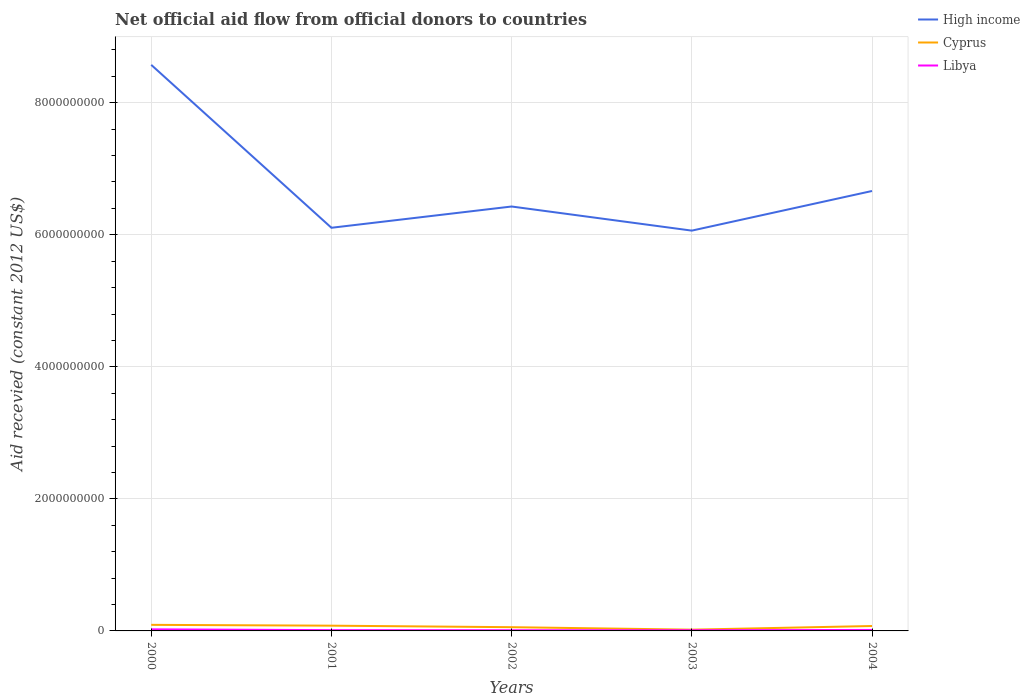Does the line corresponding to Cyprus intersect with the line corresponding to High income?
Ensure brevity in your answer.  No. Across all years, what is the maximum total aid received in Cyprus?
Keep it short and to the point. 1.92e+07. What is the total total aid received in Cyprus in the graph?
Your response must be concise. -1.78e+07. What is the difference between the highest and the second highest total aid received in High income?
Provide a succinct answer. 2.51e+09. How many lines are there?
Keep it short and to the point. 3. What is the difference between two consecutive major ticks on the Y-axis?
Give a very brief answer. 2.00e+09. Does the graph contain any zero values?
Ensure brevity in your answer.  No. Does the graph contain grids?
Ensure brevity in your answer.  Yes. Where does the legend appear in the graph?
Keep it short and to the point. Top right. How many legend labels are there?
Provide a succinct answer. 3. How are the legend labels stacked?
Offer a terse response. Vertical. What is the title of the graph?
Keep it short and to the point. Net official aid flow from official donors to countries. What is the label or title of the X-axis?
Make the answer very short. Years. What is the label or title of the Y-axis?
Ensure brevity in your answer.  Aid recevied (constant 2012 US$). What is the Aid recevied (constant 2012 US$) of High income in 2000?
Provide a short and direct response. 8.57e+09. What is the Aid recevied (constant 2012 US$) in Cyprus in 2000?
Ensure brevity in your answer.  9.20e+07. What is the Aid recevied (constant 2012 US$) of Libya in 2000?
Give a very brief answer. 2.38e+07. What is the Aid recevied (constant 2012 US$) of High income in 2001?
Provide a short and direct response. 6.11e+09. What is the Aid recevied (constant 2012 US$) in Cyprus in 2001?
Keep it short and to the point. 7.95e+07. What is the Aid recevied (constant 2012 US$) of Libya in 2001?
Provide a short and direct response. 1.17e+07. What is the Aid recevied (constant 2012 US$) of High income in 2002?
Your answer should be compact. 6.43e+09. What is the Aid recevied (constant 2012 US$) of Cyprus in 2002?
Your answer should be very brief. 5.66e+07. What is the Aid recevied (constant 2012 US$) in Libya in 2002?
Offer a terse response. 1.05e+07. What is the Aid recevied (constant 2012 US$) of High income in 2003?
Your answer should be compact. 6.06e+09. What is the Aid recevied (constant 2012 US$) in Cyprus in 2003?
Provide a short and direct response. 1.92e+07. What is the Aid recevied (constant 2012 US$) in Libya in 2003?
Give a very brief answer. 1.03e+07. What is the Aid recevied (constant 2012 US$) of High income in 2004?
Provide a short and direct response. 6.66e+09. What is the Aid recevied (constant 2012 US$) in Cyprus in 2004?
Offer a terse response. 7.44e+07. What is the Aid recevied (constant 2012 US$) in Libya in 2004?
Offer a very short reply. 1.50e+07. Across all years, what is the maximum Aid recevied (constant 2012 US$) in High income?
Ensure brevity in your answer.  8.57e+09. Across all years, what is the maximum Aid recevied (constant 2012 US$) of Cyprus?
Give a very brief answer. 9.20e+07. Across all years, what is the maximum Aid recevied (constant 2012 US$) in Libya?
Provide a succinct answer. 2.38e+07. Across all years, what is the minimum Aid recevied (constant 2012 US$) of High income?
Your response must be concise. 6.06e+09. Across all years, what is the minimum Aid recevied (constant 2012 US$) in Cyprus?
Ensure brevity in your answer.  1.92e+07. Across all years, what is the minimum Aid recevied (constant 2012 US$) in Libya?
Provide a succinct answer. 1.03e+07. What is the total Aid recevied (constant 2012 US$) of High income in the graph?
Provide a short and direct response. 3.38e+1. What is the total Aid recevied (constant 2012 US$) of Cyprus in the graph?
Your response must be concise. 3.22e+08. What is the total Aid recevied (constant 2012 US$) in Libya in the graph?
Provide a short and direct response. 7.14e+07. What is the difference between the Aid recevied (constant 2012 US$) of High income in 2000 and that in 2001?
Offer a very short reply. 2.47e+09. What is the difference between the Aid recevied (constant 2012 US$) of Cyprus in 2000 and that in 2001?
Keep it short and to the point. 1.25e+07. What is the difference between the Aid recevied (constant 2012 US$) of Libya in 2000 and that in 2001?
Provide a short and direct response. 1.21e+07. What is the difference between the Aid recevied (constant 2012 US$) in High income in 2000 and that in 2002?
Your answer should be very brief. 2.15e+09. What is the difference between the Aid recevied (constant 2012 US$) of Cyprus in 2000 and that in 2002?
Ensure brevity in your answer.  3.53e+07. What is the difference between the Aid recevied (constant 2012 US$) in Libya in 2000 and that in 2002?
Offer a terse response. 1.33e+07. What is the difference between the Aid recevied (constant 2012 US$) of High income in 2000 and that in 2003?
Keep it short and to the point. 2.51e+09. What is the difference between the Aid recevied (constant 2012 US$) of Cyprus in 2000 and that in 2003?
Your answer should be very brief. 7.27e+07. What is the difference between the Aid recevied (constant 2012 US$) of Libya in 2000 and that in 2003?
Offer a terse response. 1.34e+07. What is the difference between the Aid recevied (constant 2012 US$) of High income in 2000 and that in 2004?
Offer a very short reply. 1.91e+09. What is the difference between the Aid recevied (constant 2012 US$) in Cyprus in 2000 and that in 2004?
Provide a succinct answer. 1.76e+07. What is the difference between the Aid recevied (constant 2012 US$) in Libya in 2000 and that in 2004?
Ensure brevity in your answer.  8.78e+06. What is the difference between the Aid recevied (constant 2012 US$) of High income in 2001 and that in 2002?
Offer a very short reply. -3.22e+08. What is the difference between the Aid recevied (constant 2012 US$) of Cyprus in 2001 and that in 2002?
Make the answer very short. 2.28e+07. What is the difference between the Aid recevied (constant 2012 US$) in Libya in 2001 and that in 2002?
Your answer should be very brief. 1.22e+06. What is the difference between the Aid recevied (constant 2012 US$) in High income in 2001 and that in 2003?
Provide a succinct answer. 4.32e+07. What is the difference between the Aid recevied (constant 2012 US$) of Cyprus in 2001 and that in 2003?
Your answer should be very brief. 6.02e+07. What is the difference between the Aid recevied (constant 2012 US$) of Libya in 2001 and that in 2003?
Offer a terse response. 1.39e+06. What is the difference between the Aid recevied (constant 2012 US$) of High income in 2001 and that in 2004?
Your response must be concise. -5.57e+08. What is the difference between the Aid recevied (constant 2012 US$) of Cyprus in 2001 and that in 2004?
Offer a terse response. 5.07e+06. What is the difference between the Aid recevied (constant 2012 US$) in Libya in 2001 and that in 2004?
Make the answer very short. -3.28e+06. What is the difference between the Aid recevied (constant 2012 US$) of High income in 2002 and that in 2003?
Keep it short and to the point. 3.65e+08. What is the difference between the Aid recevied (constant 2012 US$) in Cyprus in 2002 and that in 2003?
Offer a very short reply. 3.74e+07. What is the difference between the Aid recevied (constant 2012 US$) of High income in 2002 and that in 2004?
Your answer should be compact. -2.35e+08. What is the difference between the Aid recevied (constant 2012 US$) of Cyprus in 2002 and that in 2004?
Offer a terse response. -1.78e+07. What is the difference between the Aid recevied (constant 2012 US$) of Libya in 2002 and that in 2004?
Your answer should be compact. -4.50e+06. What is the difference between the Aid recevied (constant 2012 US$) in High income in 2003 and that in 2004?
Your answer should be compact. -6.00e+08. What is the difference between the Aid recevied (constant 2012 US$) of Cyprus in 2003 and that in 2004?
Keep it short and to the point. -5.52e+07. What is the difference between the Aid recevied (constant 2012 US$) in Libya in 2003 and that in 2004?
Keep it short and to the point. -4.67e+06. What is the difference between the Aid recevied (constant 2012 US$) of High income in 2000 and the Aid recevied (constant 2012 US$) of Cyprus in 2001?
Give a very brief answer. 8.49e+09. What is the difference between the Aid recevied (constant 2012 US$) in High income in 2000 and the Aid recevied (constant 2012 US$) in Libya in 2001?
Your answer should be compact. 8.56e+09. What is the difference between the Aid recevied (constant 2012 US$) in Cyprus in 2000 and the Aid recevied (constant 2012 US$) in Libya in 2001?
Give a very brief answer. 8.02e+07. What is the difference between the Aid recevied (constant 2012 US$) of High income in 2000 and the Aid recevied (constant 2012 US$) of Cyprus in 2002?
Offer a terse response. 8.52e+09. What is the difference between the Aid recevied (constant 2012 US$) of High income in 2000 and the Aid recevied (constant 2012 US$) of Libya in 2002?
Offer a very short reply. 8.56e+09. What is the difference between the Aid recevied (constant 2012 US$) in Cyprus in 2000 and the Aid recevied (constant 2012 US$) in Libya in 2002?
Offer a terse response. 8.15e+07. What is the difference between the Aid recevied (constant 2012 US$) in High income in 2000 and the Aid recevied (constant 2012 US$) in Cyprus in 2003?
Offer a terse response. 8.55e+09. What is the difference between the Aid recevied (constant 2012 US$) in High income in 2000 and the Aid recevied (constant 2012 US$) in Libya in 2003?
Provide a short and direct response. 8.56e+09. What is the difference between the Aid recevied (constant 2012 US$) of Cyprus in 2000 and the Aid recevied (constant 2012 US$) of Libya in 2003?
Offer a terse response. 8.16e+07. What is the difference between the Aid recevied (constant 2012 US$) of High income in 2000 and the Aid recevied (constant 2012 US$) of Cyprus in 2004?
Your response must be concise. 8.50e+09. What is the difference between the Aid recevied (constant 2012 US$) of High income in 2000 and the Aid recevied (constant 2012 US$) of Libya in 2004?
Provide a short and direct response. 8.56e+09. What is the difference between the Aid recevied (constant 2012 US$) in Cyprus in 2000 and the Aid recevied (constant 2012 US$) in Libya in 2004?
Provide a short and direct response. 7.70e+07. What is the difference between the Aid recevied (constant 2012 US$) in High income in 2001 and the Aid recevied (constant 2012 US$) in Cyprus in 2002?
Give a very brief answer. 6.05e+09. What is the difference between the Aid recevied (constant 2012 US$) in High income in 2001 and the Aid recevied (constant 2012 US$) in Libya in 2002?
Make the answer very short. 6.10e+09. What is the difference between the Aid recevied (constant 2012 US$) in Cyprus in 2001 and the Aid recevied (constant 2012 US$) in Libya in 2002?
Your answer should be very brief. 6.90e+07. What is the difference between the Aid recevied (constant 2012 US$) in High income in 2001 and the Aid recevied (constant 2012 US$) in Cyprus in 2003?
Ensure brevity in your answer.  6.09e+09. What is the difference between the Aid recevied (constant 2012 US$) of High income in 2001 and the Aid recevied (constant 2012 US$) of Libya in 2003?
Offer a very short reply. 6.10e+09. What is the difference between the Aid recevied (constant 2012 US$) in Cyprus in 2001 and the Aid recevied (constant 2012 US$) in Libya in 2003?
Provide a succinct answer. 6.91e+07. What is the difference between the Aid recevied (constant 2012 US$) of High income in 2001 and the Aid recevied (constant 2012 US$) of Cyprus in 2004?
Provide a short and direct response. 6.03e+09. What is the difference between the Aid recevied (constant 2012 US$) in High income in 2001 and the Aid recevied (constant 2012 US$) in Libya in 2004?
Provide a short and direct response. 6.09e+09. What is the difference between the Aid recevied (constant 2012 US$) of Cyprus in 2001 and the Aid recevied (constant 2012 US$) of Libya in 2004?
Make the answer very short. 6.44e+07. What is the difference between the Aid recevied (constant 2012 US$) of High income in 2002 and the Aid recevied (constant 2012 US$) of Cyprus in 2003?
Give a very brief answer. 6.41e+09. What is the difference between the Aid recevied (constant 2012 US$) of High income in 2002 and the Aid recevied (constant 2012 US$) of Libya in 2003?
Your answer should be compact. 6.42e+09. What is the difference between the Aid recevied (constant 2012 US$) of Cyprus in 2002 and the Aid recevied (constant 2012 US$) of Libya in 2003?
Keep it short and to the point. 4.63e+07. What is the difference between the Aid recevied (constant 2012 US$) in High income in 2002 and the Aid recevied (constant 2012 US$) in Cyprus in 2004?
Keep it short and to the point. 6.35e+09. What is the difference between the Aid recevied (constant 2012 US$) of High income in 2002 and the Aid recevied (constant 2012 US$) of Libya in 2004?
Offer a very short reply. 6.41e+09. What is the difference between the Aid recevied (constant 2012 US$) in Cyprus in 2002 and the Aid recevied (constant 2012 US$) in Libya in 2004?
Ensure brevity in your answer.  4.16e+07. What is the difference between the Aid recevied (constant 2012 US$) in High income in 2003 and the Aid recevied (constant 2012 US$) in Cyprus in 2004?
Your answer should be very brief. 5.99e+09. What is the difference between the Aid recevied (constant 2012 US$) of High income in 2003 and the Aid recevied (constant 2012 US$) of Libya in 2004?
Give a very brief answer. 6.05e+09. What is the difference between the Aid recevied (constant 2012 US$) in Cyprus in 2003 and the Aid recevied (constant 2012 US$) in Libya in 2004?
Your answer should be compact. 4.22e+06. What is the average Aid recevied (constant 2012 US$) in High income per year?
Give a very brief answer. 6.77e+09. What is the average Aid recevied (constant 2012 US$) in Cyprus per year?
Your answer should be compact. 6.43e+07. What is the average Aid recevied (constant 2012 US$) of Libya per year?
Make the answer very short. 1.43e+07. In the year 2000, what is the difference between the Aid recevied (constant 2012 US$) in High income and Aid recevied (constant 2012 US$) in Cyprus?
Keep it short and to the point. 8.48e+09. In the year 2000, what is the difference between the Aid recevied (constant 2012 US$) of High income and Aid recevied (constant 2012 US$) of Libya?
Keep it short and to the point. 8.55e+09. In the year 2000, what is the difference between the Aid recevied (constant 2012 US$) in Cyprus and Aid recevied (constant 2012 US$) in Libya?
Offer a very short reply. 6.82e+07. In the year 2001, what is the difference between the Aid recevied (constant 2012 US$) of High income and Aid recevied (constant 2012 US$) of Cyprus?
Offer a terse response. 6.03e+09. In the year 2001, what is the difference between the Aid recevied (constant 2012 US$) in High income and Aid recevied (constant 2012 US$) in Libya?
Your answer should be very brief. 6.09e+09. In the year 2001, what is the difference between the Aid recevied (constant 2012 US$) of Cyprus and Aid recevied (constant 2012 US$) of Libya?
Your answer should be very brief. 6.77e+07. In the year 2002, what is the difference between the Aid recevied (constant 2012 US$) of High income and Aid recevied (constant 2012 US$) of Cyprus?
Your answer should be compact. 6.37e+09. In the year 2002, what is the difference between the Aid recevied (constant 2012 US$) in High income and Aid recevied (constant 2012 US$) in Libya?
Your answer should be very brief. 6.42e+09. In the year 2002, what is the difference between the Aid recevied (constant 2012 US$) in Cyprus and Aid recevied (constant 2012 US$) in Libya?
Offer a very short reply. 4.61e+07. In the year 2003, what is the difference between the Aid recevied (constant 2012 US$) of High income and Aid recevied (constant 2012 US$) of Cyprus?
Offer a very short reply. 6.04e+09. In the year 2003, what is the difference between the Aid recevied (constant 2012 US$) of High income and Aid recevied (constant 2012 US$) of Libya?
Provide a succinct answer. 6.05e+09. In the year 2003, what is the difference between the Aid recevied (constant 2012 US$) of Cyprus and Aid recevied (constant 2012 US$) of Libya?
Provide a short and direct response. 8.89e+06. In the year 2004, what is the difference between the Aid recevied (constant 2012 US$) in High income and Aid recevied (constant 2012 US$) in Cyprus?
Offer a terse response. 6.59e+09. In the year 2004, what is the difference between the Aid recevied (constant 2012 US$) of High income and Aid recevied (constant 2012 US$) of Libya?
Provide a short and direct response. 6.65e+09. In the year 2004, what is the difference between the Aid recevied (constant 2012 US$) in Cyprus and Aid recevied (constant 2012 US$) in Libya?
Make the answer very short. 5.94e+07. What is the ratio of the Aid recevied (constant 2012 US$) in High income in 2000 to that in 2001?
Give a very brief answer. 1.4. What is the ratio of the Aid recevied (constant 2012 US$) in Cyprus in 2000 to that in 2001?
Your response must be concise. 1.16. What is the ratio of the Aid recevied (constant 2012 US$) in Libya in 2000 to that in 2001?
Provide a short and direct response. 2.03. What is the ratio of the Aid recevied (constant 2012 US$) in High income in 2000 to that in 2002?
Offer a very short reply. 1.33. What is the ratio of the Aid recevied (constant 2012 US$) of Cyprus in 2000 to that in 2002?
Your answer should be very brief. 1.62. What is the ratio of the Aid recevied (constant 2012 US$) of Libya in 2000 to that in 2002?
Make the answer very short. 2.26. What is the ratio of the Aid recevied (constant 2012 US$) in High income in 2000 to that in 2003?
Provide a succinct answer. 1.41. What is the ratio of the Aid recevied (constant 2012 US$) in Cyprus in 2000 to that in 2003?
Give a very brief answer. 4.78. What is the ratio of the Aid recevied (constant 2012 US$) of Libya in 2000 to that in 2003?
Offer a very short reply. 2.3. What is the ratio of the Aid recevied (constant 2012 US$) in High income in 2000 to that in 2004?
Your answer should be very brief. 1.29. What is the ratio of the Aid recevied (constant 2012 US$) in Cyprus in 2000 to that in 2004?
Give a very brief answer. 1.24. What is the ratio of the Aid recevied (constant 2012 US$) of Libya in 2000 to that in 2004?
Keep it short and to the point. 1.58. What is the ratio of the Aid recevied (constant 2012 US$) in High income in 2001 to that in 2002?
Offer a very short reply. 0.95. What is the ratio of the Aid recevied (constant 2012 US$) in Cyprus in 2001 to that in 2002?
Give a very brief answer. 1.4. What is the ratio of the Aid recevied (constant 2012 US$) in Libya in 2001 to that in 2002?
Offer a terse response. 1.12. What is the ratio of the Aid recevied (constant 2012 US$) of High income in 2001 to that in 2003?
Ensure brevity in your answer.  1.01. What is the ratio of the Aid recevied (constant 2012 US$) of Cyprus in 2001 to that in 2003?
Offer a very short reply. 4.13. What is the ratio of the Aid recevied (constant 2012 US$) in Libya in 2001 to that in 2003?
Provide a short and direct response. 1.13. What is the ratio of the Aid recevied (constant 2012 US$) in High income in 2001 to that in 2004?
Your answer should be compact. 0.92. What is the ratio of the Aid recevied (constant 2012 US$) in Cyprus in 2001 to that in 2004?
Provide a succinct answer. 1.07. What is the ratio of the Aid recevied (constant 2012 US$) in Libya in 2001 to that in 2004?
Your answer should be compact. 0.78. What is the ratio of the Aid recevied (constant 2012 US$) in High income in 2002 to that in 2003?
Your answer should be compact. 1.06. What is the ratio of the Aid recevied (constant 2012 US$) of Cyprus in 2002 to that in 2003?
Offer a very short reply. 2.94. What is the ratio of the Aid recevied (constant 2012 US$) of Libya in 2002 to that in 2003?
Your answer should be very brief. 1.02. What is the ratio of the Aid recevied (constant 2012 US$) of High income in 2002 to that in 2004?
Ensure brevity in your answer.  0.96. What is the ratio of the Aid recevied (constant 2012 US$) in Cyprus in 2002 to that in 2004?
Provide a succinct answer. 0.76. What is the ratio of the Aid recevied (constant 2012 US$) in Libya in 2002 to that in 2004?
Your answer should be very brief. 0.7. What is the ratio of the Aid recevied (constant 2012 US$) in High income in 2003 to that in 2004?
Provide a succinct answer. 0.91. What is the ratio of the Aid recevied (constant 2012 US$) of Cyprus in 2003 to that in 2004?
Your answer should be very brief. 0.26. What is the ratio of the Aid recevied (constant 2012 US$) in Libya in 2003 to that in 2004?
Provide a succinct answer. 0.69. What is the difference between the highest and the second highest Aid recevied (constant 2012 US$) in High income?
Provide a succinct answer. 1.91e+09. What is the difference between the highest and the second highest Aid recevied (constant 2012 US$) of Cyprus?
Ensure brevity in your answer.  1.25e+07. What is the difference between the highest and the second highest Aid recevied (constant 2012 US$) of Libya?
Make the answer very short. 8.78e+06. What is the difference between the highest and the lowest Aid recevied (constant 2012 US$) of High income?
Your answer should be compact. 2.51e+09. What is the difference between the highest and the lowest Aid recevied (constant 2012 US$) in Cyprus?
Keep it short and to the point. 7.27e+07. What is the difference between the highest and the lowest Aid recevied (constant 2012 US$) in Libya?
Give a very brief answer. 1.34e+07. 